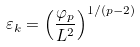<formula> <loc_0><loc_0><loc_500><loc_500>\varepsilon _ { k } = \left ( \frac { \varphi _ { p } } { L ^ { 2 } } \right ) ^ { 1 / ( p - 2 ) }</formula> 